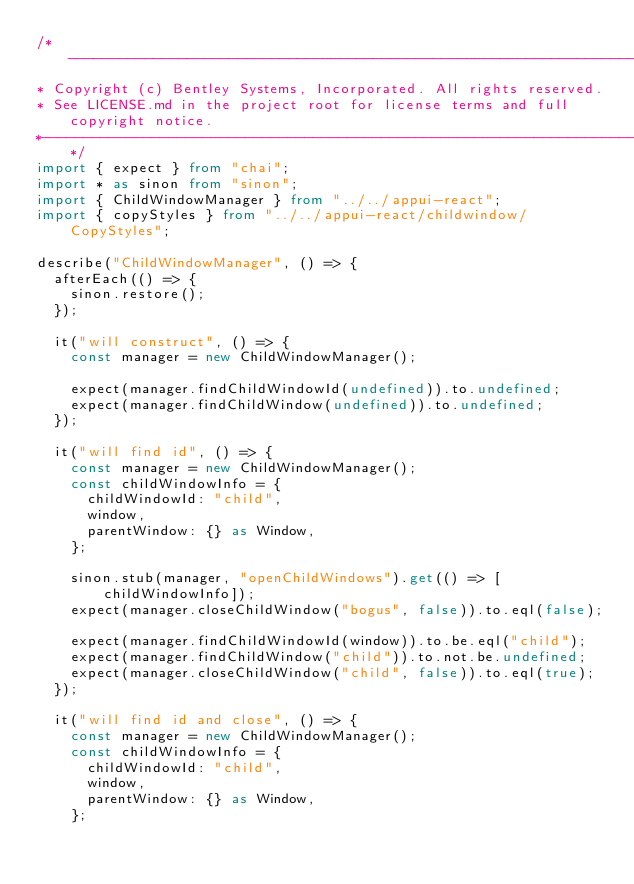<code> <loc_0><loc_0><loc_500><loc_500><_TypeScript_>/*---------------------------------------------------------------------------------------------
* Copyright (c) Bentley Systems, Incorporated. All rights reserved.
* See LICENSE.md in the project root for license terms and full copyright notice.
*--------------------------------------------------------------------------------------------*/
import { expect } from "chai";
import * as sinon from "sinon";
import { ChildWindowManager } from "../../appui-react";
import { copyStyles } from "../../appui-react/childwindow/CopyStyles";

describe("ChildWindowManager", () => {
  afterEach(() => {
    sinon.restore();
  });

  it("will construct", () => {
    const manager = new ChildWindowManager();

    expect(manager.findChildWindowId(undefined)).to.undefined;
    expect(manager.findChildWindow(undefined)).to.undefined;
  });

  it("will find id", () => {
    const manager = new ChildWindowManager();
    const childWindowInfo = {
      childWindowId: "child",
      window,
      parentWindow: {} as Window,
    };

    sinon.stub(manager, "openChildWindows").get(() => [childWindowInfo]);
    expect(manager.closeChildWindow("bogus", false)).to.eql(false);

    expect(manager.findChildWindowId(window)).to.be.eql("child");
    expect(manager.findChildWindow("child")).to.not.be.undefined;
    expect(manager.closeChildWindow("child", false)).to.eql(true);
  });

  it("will find id and close", () => {
    const manager = new ChildWindowManager();
    const childWindowInfo = {
      childWindowId: "child",
      window,
      parentWindow: {} as Window,
    };
</code> 